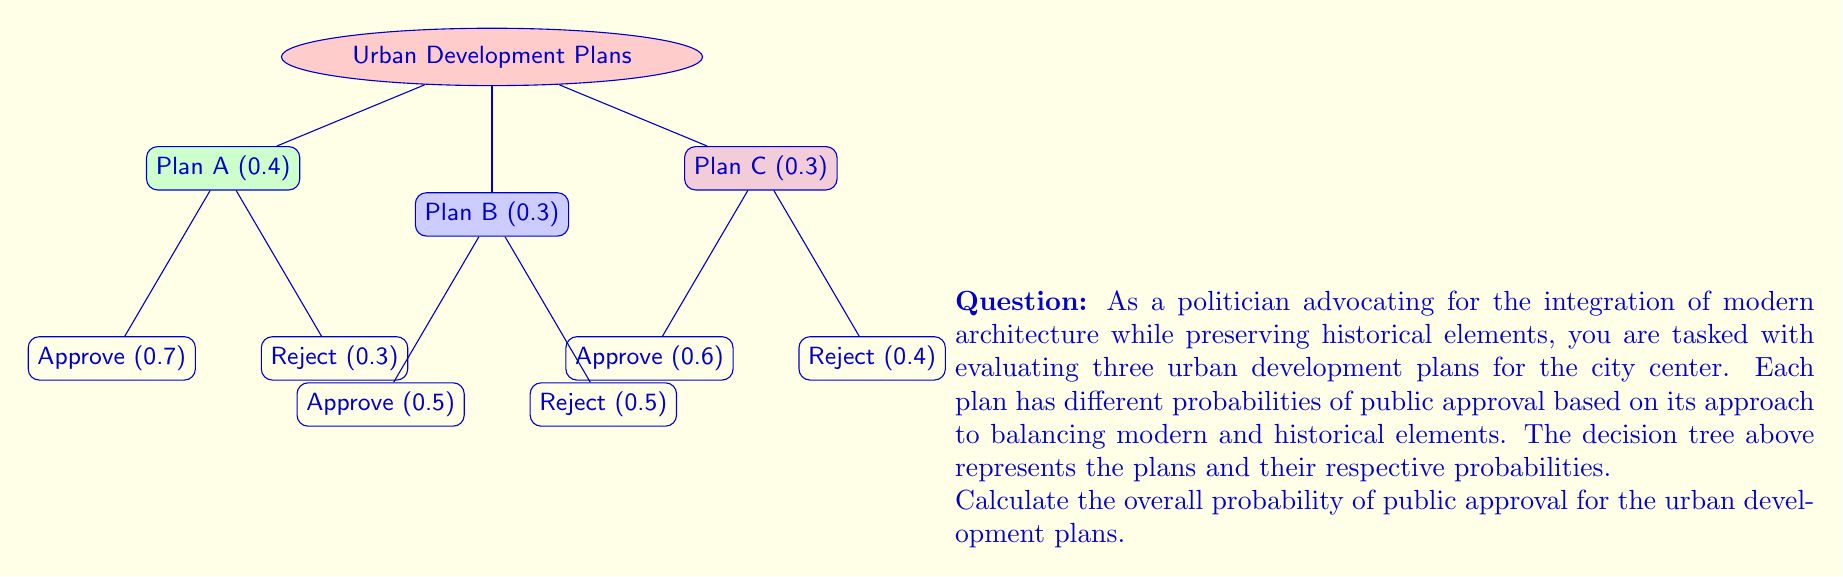Teach me how to tackle this problem. To calculate the overall probability of public approval, we need to sum the probabilities of approval for each plan, considering the probability of each plan being chosen.

1. For Plan A:
   Probability of choosing Plan A = 0.4
   Probability of approval for Plan A = 0.7
   $P(\text{Approval | Plan A}) = 0.4 \times 0.7 = 0.28$

2. For Plan B:
   Probability of choosing Plan B = 0.3
   Probability of approval for Plan B = 0.5
   $P(\text{Approval | Plan B}) = 0.3 \times 0.5 = 0.15$

3. For Plan C:
   Probability of choosing Plan C = 0.3
   Probability of approval for Plan C = 0.6
   $P(\text{Approval | Plan C}) = 0.3 \times 0.6 = 0.18$

4. Overall probability of approval:
   $P(\text{Approval}) = P(\text{Approval | Plan A}) + P(\text{Approval | Plan B}) + P(\text{Approval | Plan C})$
   $P(\text{Approval}) = 0.28 + 0.15 + 0.18 = 0.61$

Therefore, the overall probability of public approval for the urban development plans is 0.61 or 61%.
Answer: 0.61 